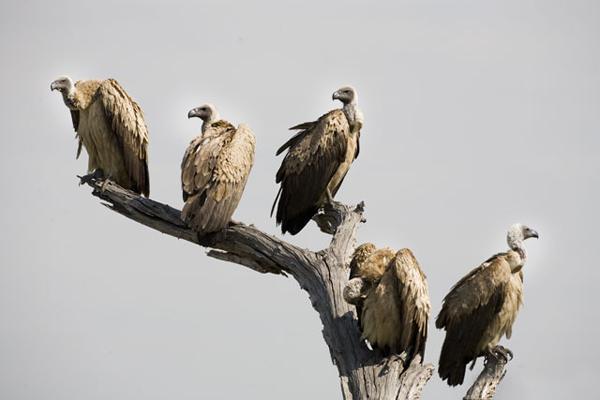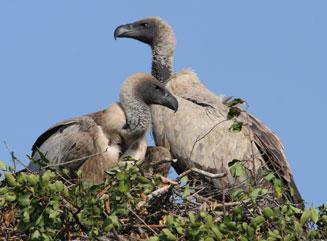The first image is the image on the left, the second image is the image on the right. Assess this claim about the two images: "One image shows exactly two vultures in a nest of sticks and leaves, and the other image shows several vultures perched on leafless branches.". Correct or not? Answer yes or no. Yes. The first image is the image on the left, the second image is the image on the right. Considering the images on both sides, is "Birds are sitting on tree branches in both images." valid? Answer yes or no. Yes. 